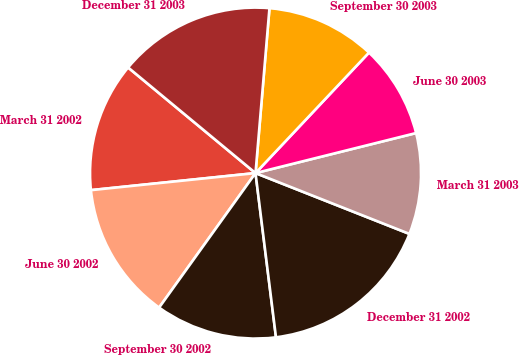Convert chart to OTSL. <chart><loc_0><loc_0><loc_500><loc_500><pie_chart><fcel>March 31 2002<fcel>June 30 2002<fcel>September 30 2002<fcel>December 31 2002<fcel>March 31 2003<fcel>June 30 2003<fcel>September 30 2003<fcel>December 31 2003<nl><fcel>12.66%<fcel>13.46%<fcel>11.87%<fcel>17.04%<fcel>9.88%<fcel>9.09%<fcel>10.68%<fcel>15.33%<nl></chart> 